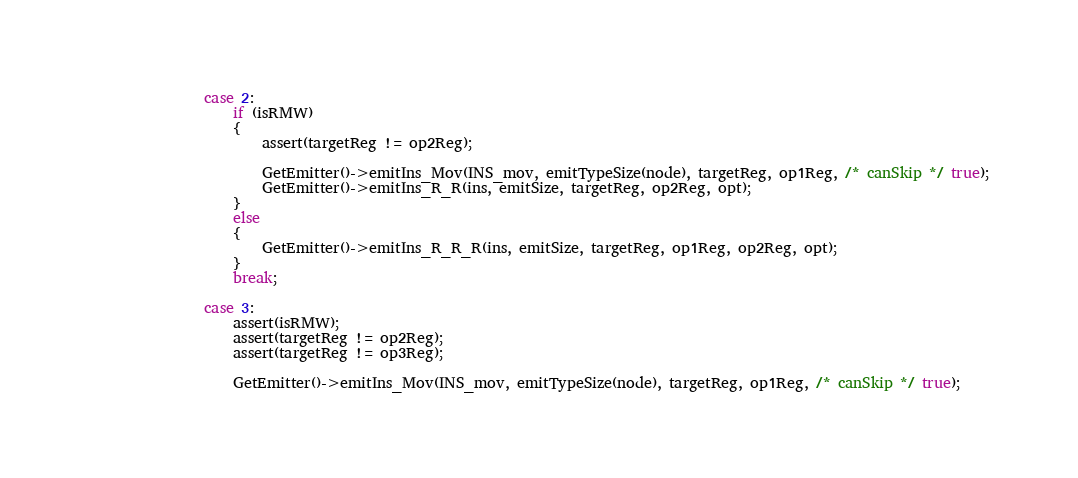Convert code to text. <code><loc_0><loc_0><loc_500><loc_500><_C++_>                case 2:
                    if (isRMW)
                    {
                        assert(targetReg != op2Reg);

                        GetEmitter()->emitIns_Mov(INS_mov, emitTypeSize(node), targetReg, op1Reg, /* canSkip */ true);
                        GetEmitter()->emitIns_R_R(ins, emitSize, targetReg, op2Reg, opt);
                    }
                    else
                    {
                        GetEmitter()->emitIns_R_R_R(ins, emitSize, targetReg, op1Reg, op2Reg, opt);
                    }
                    break;

                case 3:
                    assert(isRMW);
                    assert(targetReg != op2Reg);
                    assert(targetReg != op3Reg);

                    GetEmitter()->emitIns_Mov(INS_mov, emitTypeSize(node), targetReg, op1Reg, /* canSkip */ true);</code> 